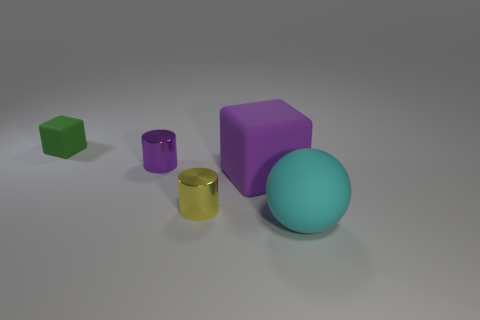Add 1 matte things. How many objects exist? 6 Subtract all blocks. How many objects are left? 3 Subtract all tiny green rubber balls. Subtract all large things. How many objects are left? 3 Add 3 tiny purple objects. How many tiny purple objects are left? 4 Add 4 big metallic cylinders. How many big metallic cylinders exist? 4 Subtract 1 green cubes. How many objects are left? 4 